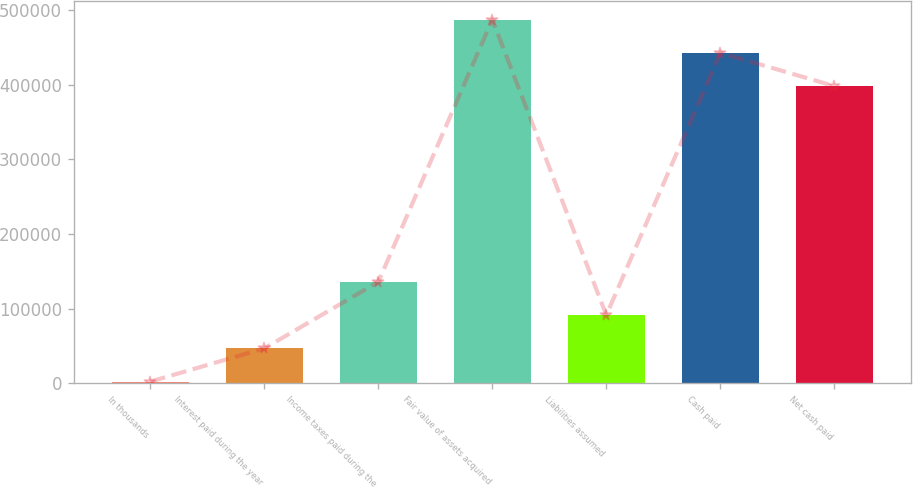Convert chart to OTSL. <chart><loc_0><loc_0><loc_500><loc_500><bar_chart><fcel>In thousands<fcel>Interest paid during the year<fcel>Income taxes paid during the<fcel>Fair value of assets acquired<fcel>Liabilities assumed<fcel>Cash paid<fcel>Net cash paid<nl><fcel>2008<fcel>46547.8<fcel>135627<fcel>487212<fcel>91087.6<fcel>442672<fcel>398132<nl></chart> 